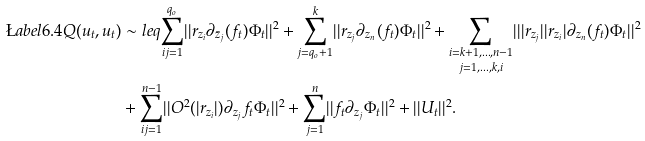<formula> <loc_0><loc_0><loc_500><loc_500>\L a b e l { 6 . 4 } Q ( u _ { t } , u _ { t } ) & \sim l e q \underset { i j = 1 } { \overset { q _ { o } } \sum } | | r _ { z _ { i } } \partial _ { \bar { z } _ { j } } ( f _ { t } ) \Phi _ { t } | | ^ { 2 } + \underset { j = q _ { o } + 1 } { \overset { k } { \sum } } | | r _ { z _ { j } } \partial _ { z _ { n } } ( f _ { t } ) \Phi _ { t } | | ^ { 2 } + \underset { j = 1 , \dots , k , i } { \underset { i = k + 1 , \dots , n - 1 } \sum } | | | r _ { z _ { j } } | | r _ { z _ { i } } | \partial _ { z _ { n } } ( f _ { t } ) \Phi _ { t } | | ^ { 2 } \\ & + \underset { i j = 1 } { \overset { n - 1 } \sum } | | O ^ { 2 } ( | r _ { z _ { i } } | ) \partial _ { z _ { j } } f _ { t } \Phi _ { t } | | ^ { 2 } + \underset { j = 1 } { \overset { n } { \sum } } | | f _ { t } \partial _ { z _ { j } } \Phi _ { t } | | ^ { 2 } + | | U _ { t } | | ^ { 2 } .</formula> 